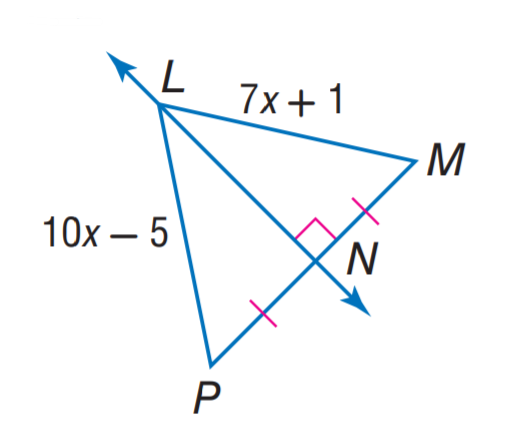Question: Find L P.
Choices:
A. 7
B. 10
C. 12
D. 15
Answer with the letter. Answer: D 